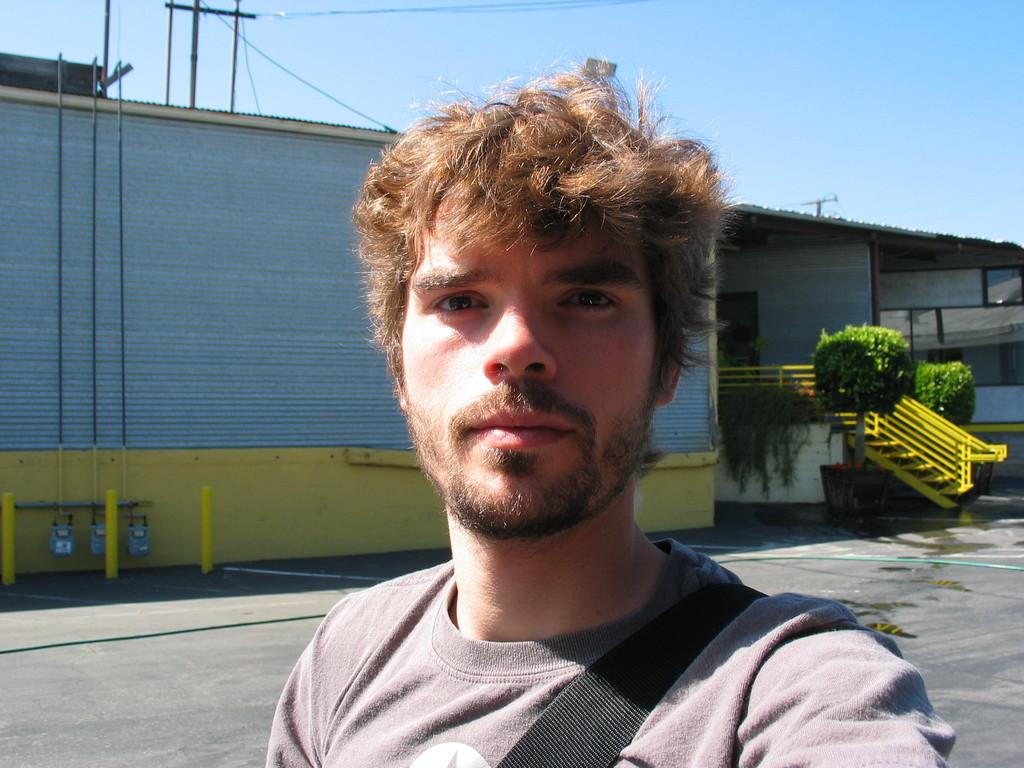What is the person in the image doing? There is a person standing on the road in the image. What can be seen near the person? There is railing in the image. What type of object is present in the image that contains plants? There is a planter in the image. What are the tall, vertical structures in the image? There are poles in the image. What is visible in the background of the image? The sky is visible in the image. Is there a boat visible in the image, and is the person a spy in the image? There is no boat or indication of spying in the image; it only shows a person standing on the road, railing, a planter, poles, and the sky. 